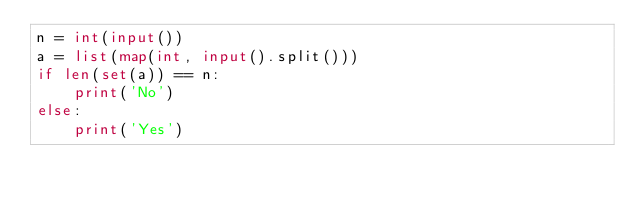<code> <loc_0><loc_0><loc_500><loc_500><_Python_>n = int(input())
a = list(map(int, input().split()))
if len(set(a)) == n:
    print('No')
else:
    print('Yes')
</code> 